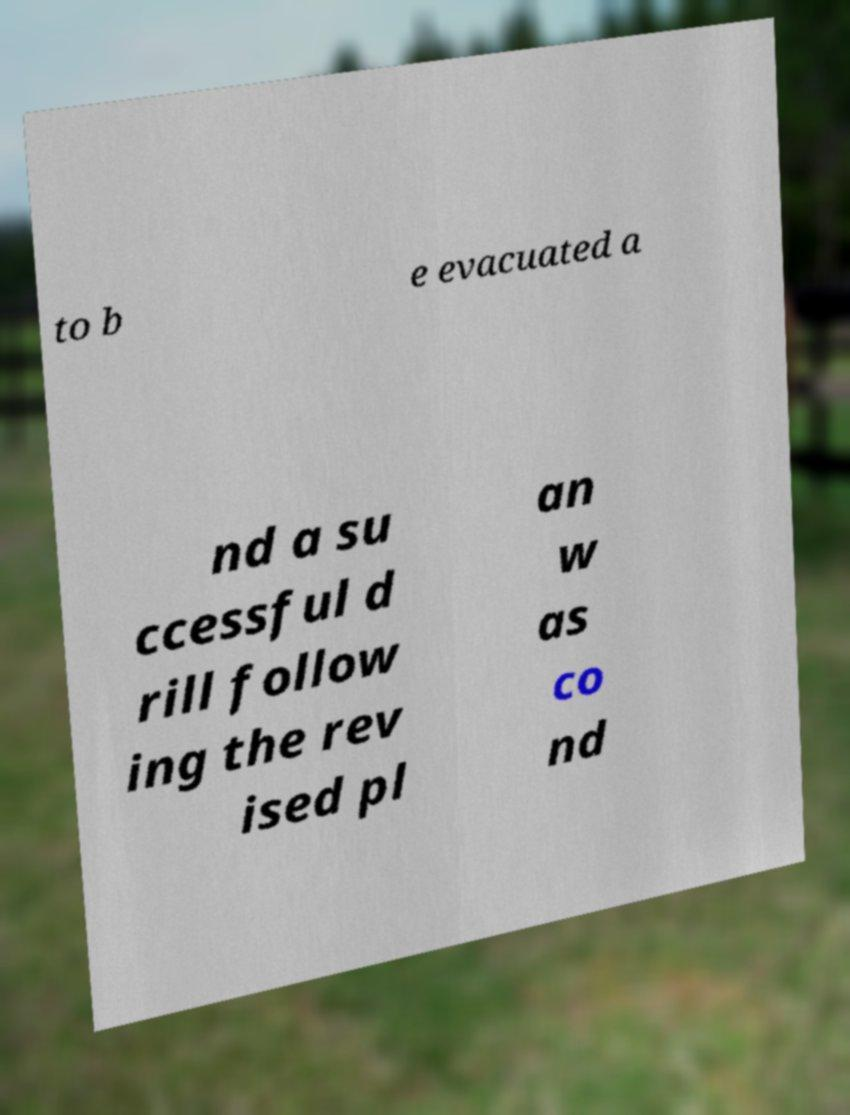Please identify and transcribe the text found in this image. to b e evacuated a nd a su ccessful d rill follow ing the rev ised pl an w as co nd 